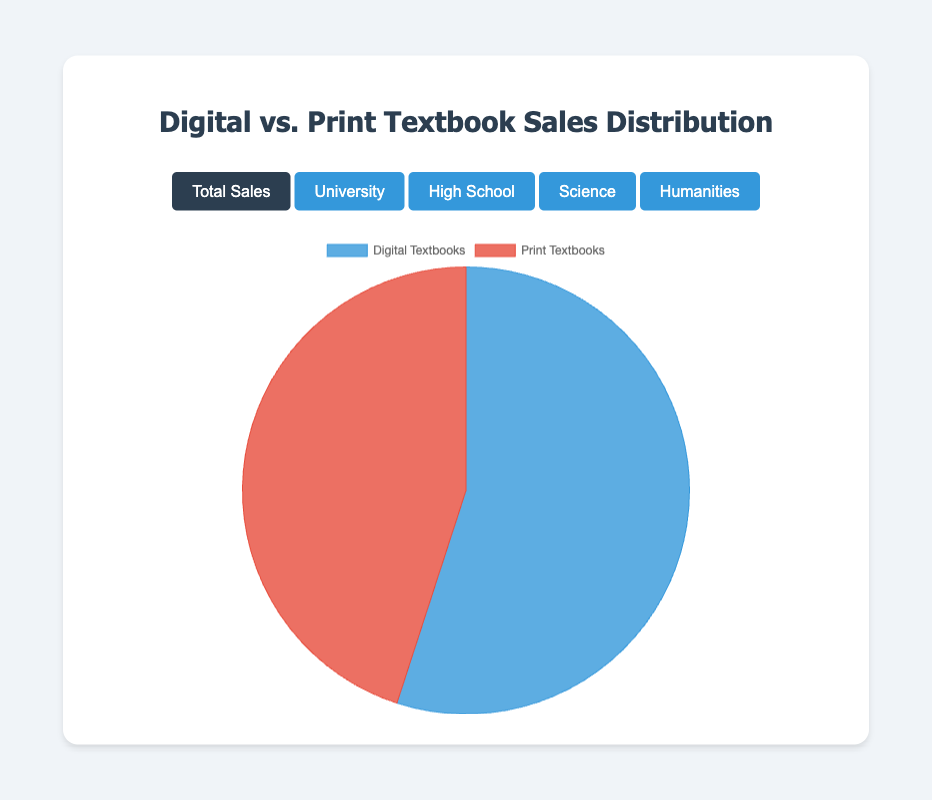What is the percentage distribution of Digital Textbooks in the "Total Sales Distribution" pie chart? In the "Total Sales Distribution" pie chart, the Digital Textbooks segment occupies 55% of the area. This is directly labeled in the chart.
Answer: 55% What is the percentage distribution of Print Textbooks in the "University Adoption Rates" pie chart? In the "University Adoption Rates" pie chart, the Print Textbooks segment covers 40% of the area. This is directly labeled in the chart.
Answer: 40% Which segment occupies a larger percentage in the "Humanities Subject - Total Sales" pie chart? In the "Humanities Subject - Total Sales" pie chart, the Print Textbooks segment occupies 60%, while the Digital Textbooks segment occupies 40%. Print Textbooks have a larger share.
Answer: Print Textbooks How does the percentage of Digital Textbooks in "University Adoption Rates" compare to that in "High School Adoption Rates"? In "University Adoption Rates," Digital Textbooks have a percentage of 60%, while in "High School Adoption Rates," they have a percentage of 50%. University rates are higher by 10%.
Answer: 10% What is the combined percentage of Digital Textbooks in "Science Subject - Total Sales" and "Humanities Subject - Total Sales"? The combined percentage is calculated by adding 70% for Science Subject and 40% for Humanities Subject, which equals 110%.
Answer: 110% What is the difference in percentage points between Digital and Print Textbooks in "High School Adoption Rates"? In the "High School Adoption Rates" pie chart, both Digital and Print Textbooks are equal at 50%. Hence, the difference is 0%.
Answer: 0% Which category has the smallest percentage in "Science Subject - Total Sales"? The "Science Subject - Total Sales" pie chart shows Print Textbooks at 30%, which is smaller compared to Digital Textbooks at 70%.
Answer: Print Textbooks Which chart depicts an equal adoption rate for both Digital and Print Textbooks? The "High School Adoption Rates" pie chart shows both Digital and Print Textbooks at 50%, indicating an equal adoption rate.
Answer: High School Adoption Rates What is the average percentage of Digital Textbooks across all pie charts provided? To find the average: (55% for Total Sales + 60% for University + 50% for High School + 70% for Science + 40% for Humanities) / 5 = 55%.
Answer: 55% What is the visual color representation of Print Textbooks in the charts? The charts use red to represent the Print Textbooks category.
Answer: Red 